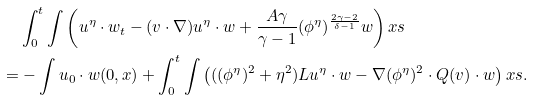Convert formula to latex. <formula><loc_0><loc_0><loc_500><loc_500>& \int _ { 0 } ^ { t } \int \left ( u ^ { \eta } \cdot w _ { t } - ( v \cdot \nabla ) u ^ { \eta } \cdot w + \frac { A \gamma } { \gamma - 1 } ( \phi ^ { \eta } ) ^ { \frac { 2 \gamma - 2 } { \delta - 1 } } w \right ) x s \\ = & - \int u _ { 0 } \cdot w ( 0 , x ) + \int _ { 0 } ^ { t } \int \left ( ( ( \phi ^ { \eta } ) ^ { 2 } + \eta ^ { 2 } ) L u ^ { \eta } \cdot w - \nabla ( \phi ^ { \eta } ) ^ { 2 } \cdot Q ( v ) \cdot w \right ) x s .</formula> 